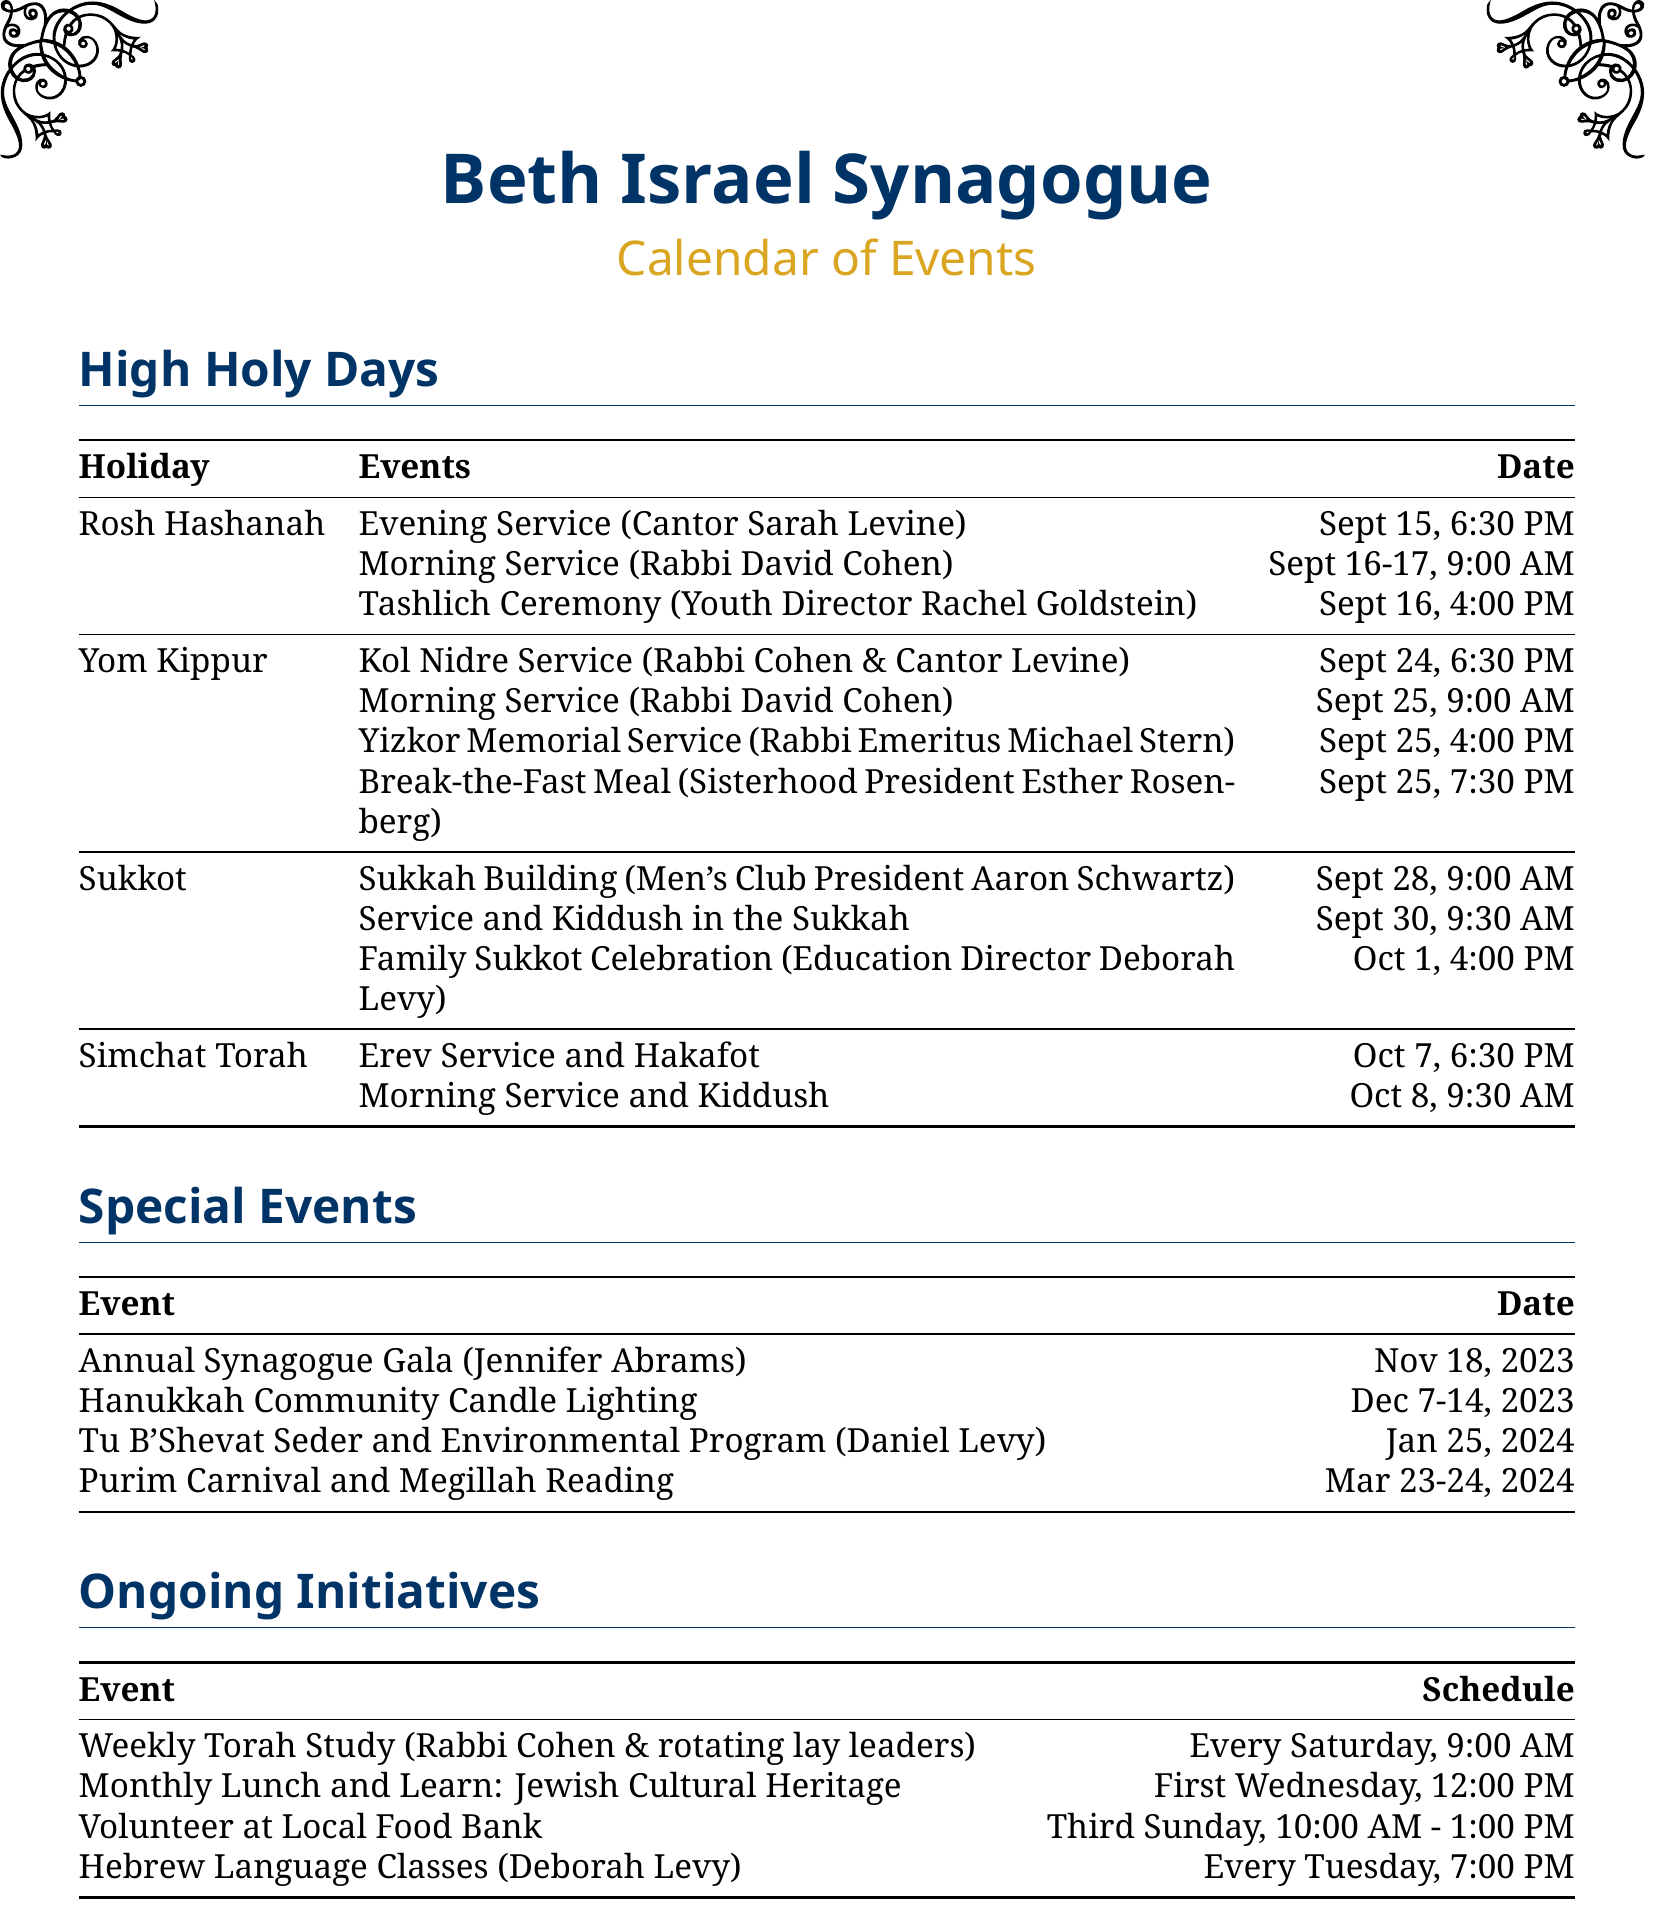What is the date of Rosh Hashanah? Rosh Hashanah is celebrated on September 15-17, 2023.
Answer: September 15-17, 2023 Who is responsible for the Yizkor Memorial Service? The Yizkor Memorial Service is led by Rabbi Emeritus Michael Stern.
Answer: Rabbi Emeritus Michael Stern When does the Family Sukkot Celebration take place? The Family Sukkot Celebration is on October 1, 2023.
Answer: October 1, 2023 What event is scheduled for January 25, 2024? A Tu B'Shevat Seder and Environmental Awareness Program is scheduled for that date.
Answer: Tu B'Shevat Seder and Environmental Awareness Program Who leads the Weekly Torah Study? The Weekly Torah Study is led by Rabbi David Cohen and rotating lay leaders.
Answer: Rabbi David Cohen and rotating lay leaders What is the time for the Kol Nidre Service? The Kol Nidre Service occurs at 6:30 PM on September 24.
Answer: 6:30 PM How many events are listed for the holiday of Sukkot? There are three events listed for Sukkot.
Answer: Three events Which committee is responsible for the annual gala? The Fundraising Committee Chair Jennifer Abrams is responsible for the gala.
Answer: Fundraising Committee Chair Jennifer Abrams What day of the week does the Hebrew Language Class take place? The Hebrew Language Class is held on Tuesday.
Answer: Tuesday 